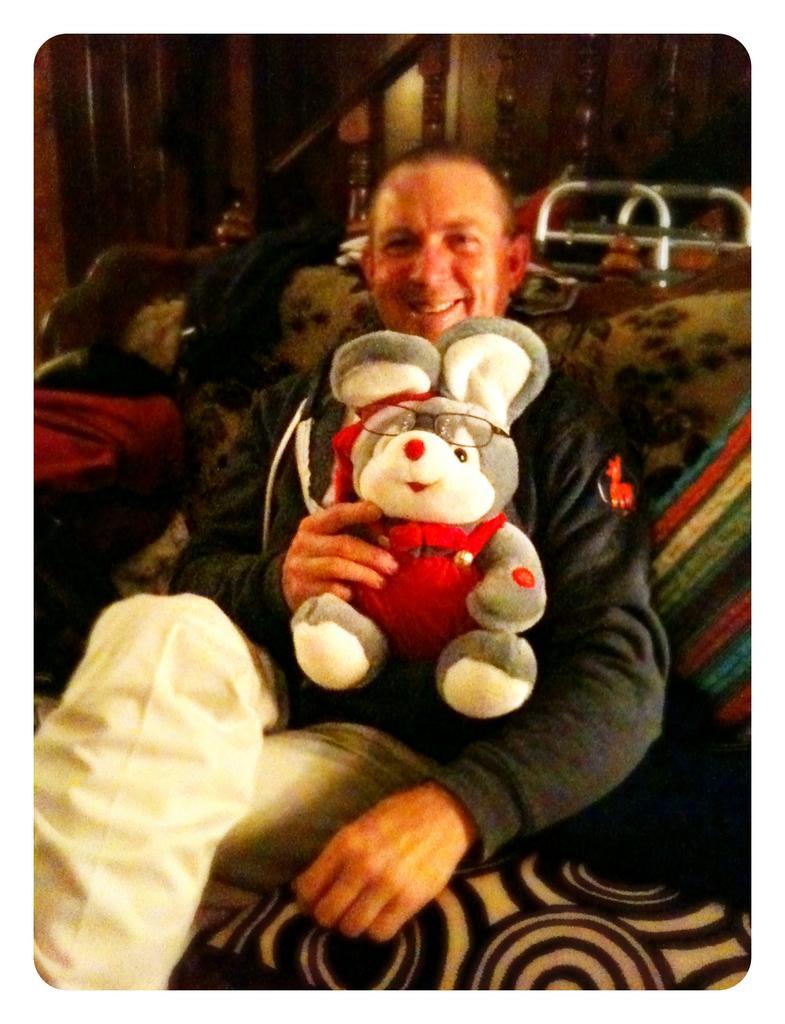Can you describe this image briefly? The picture consists of a person holding a teddy bear and sitting on a couch, on the couch they are bag, pillow and other object. In the background there are table, staircase and other objects. 